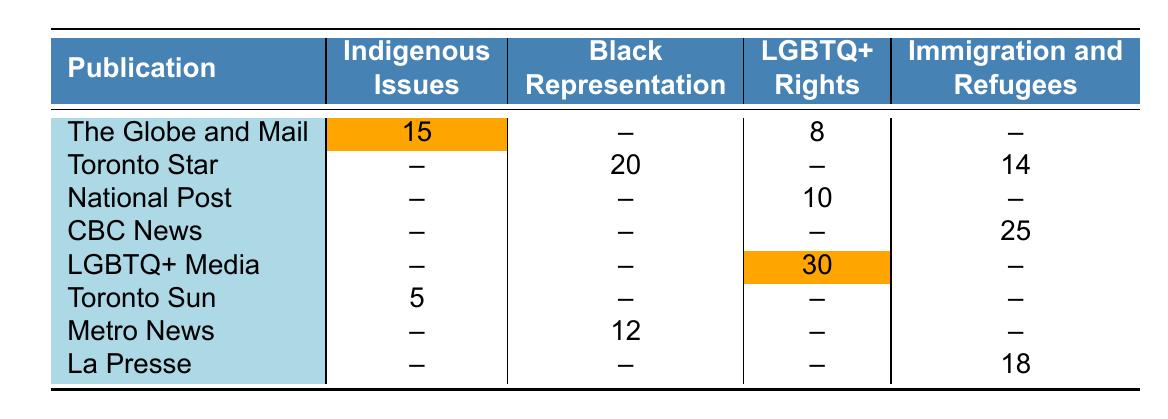What publication has the highest coverage count for LGBTQ+ rights? By looking at the "LGBTQ+ Rights" column, we see that "LGBTQ+ Media" has the highest count of 30.
Answer: LGBTQ+ Media How many coverage counts are dedicated to Indigenous Issues in total? The totals for Indigenous Issues come from "The Globe and Mail" with 15 and "Toronto Sun" with 5. Therefore, we add 15 + 5 = 20.
Answer: 20 Does the Toronto Star cover Indigenous Issues? Looking at the Toronto Star row, there is no coverage count for Indigenous Issues, indicating that it is not covered.
Answer: No Which publication has the least coverage count for Black Representation? "Metro News" has a coverage count of 12 for Black Representation, which is the lowest in that category compared to the Toronto Star's 20.
Answer: Metro News What is the difference in coverage count for Immigration and Refugees between CBC News and La Presse? CBC News has 25 counts and La Presse has 18 counts. The difference is calculated as 25 - 18 = 7.
Answer: 7 Which topic category has the highest overall coverage count across all publications? By summing the coverage counts for each category, Indigenous Issues (20), Black Representation (32), LGBTQ+ Rights (38), and Immigration and Refugees (43), we find that Immigration and Refugees has the highest count at 43.
Answer: Immigration and Refugees Is there any coverage for Black Representation in the National Post? Checking the National Post row, we see there is no coverage count listed for Black Representation.
Answer: No What percentage of total coverage for LGBTQ+ Rights comes from LGBTQ+ Media? First, we note that the total coverage for LGBTQ+ Rights is 30 (LGBTQ+ Media) + 8 (The Globe and Mail) + 10 (National Post) = 48. To find the percentage from LGBTQ+ Media, we calculate (30/48) * 100, which equals 62.5%.
Answer: 62.5% 